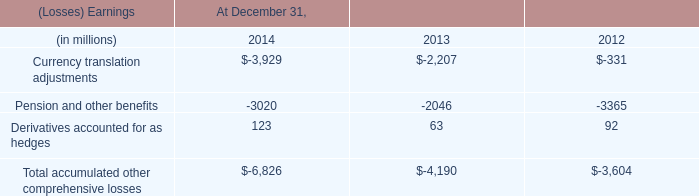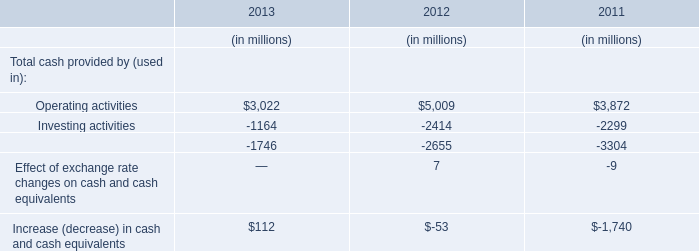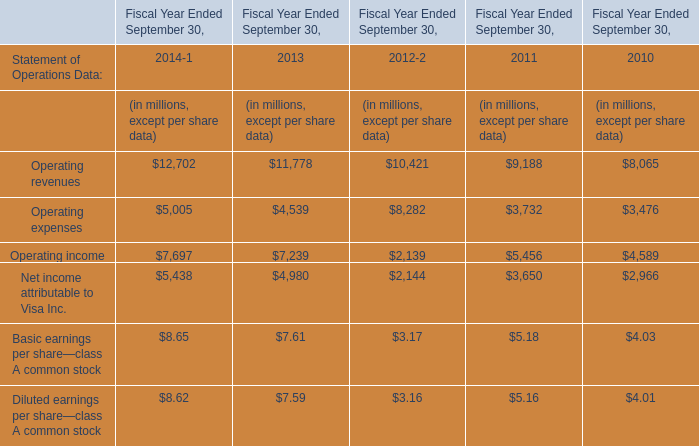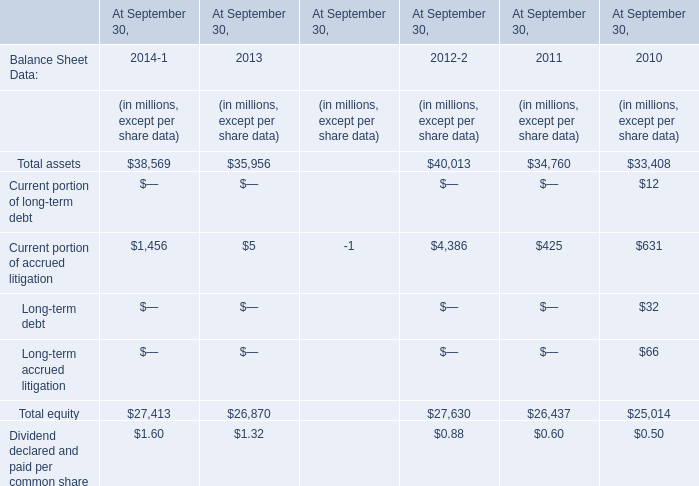In the year with lowest amount of Current portion of accrued litigation, what's the increasing rate of total asset? 
Computations: ((35956 - 40013) / 40013)
Answer: -0.10139. 